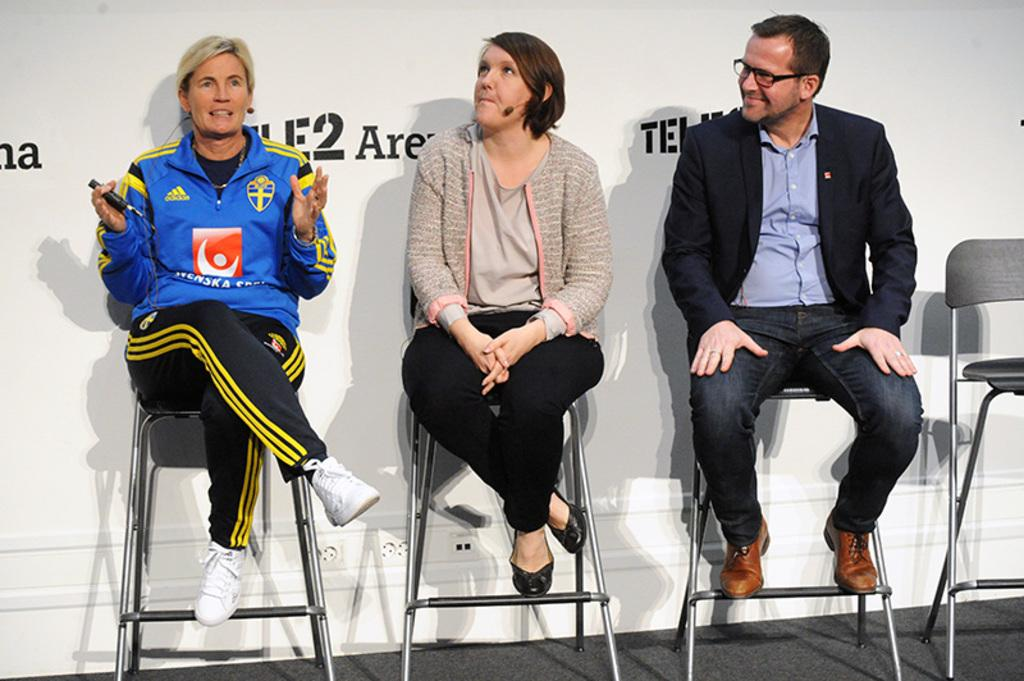How many people are present in the image? There are three people in the image. What are the people doing in the image? The people are sitting on chairs. What can be seen in the background of the image? There is a wall in the background of the image. What is written or displayed on the wall? There is text on the wall. What type of fork is being used by the people in the image? There is no fork present in the image; the people are sitting on chairs. What level of need is being addressed by the people in the image? The image does not convey any information about the level of need being addressed by the people. 